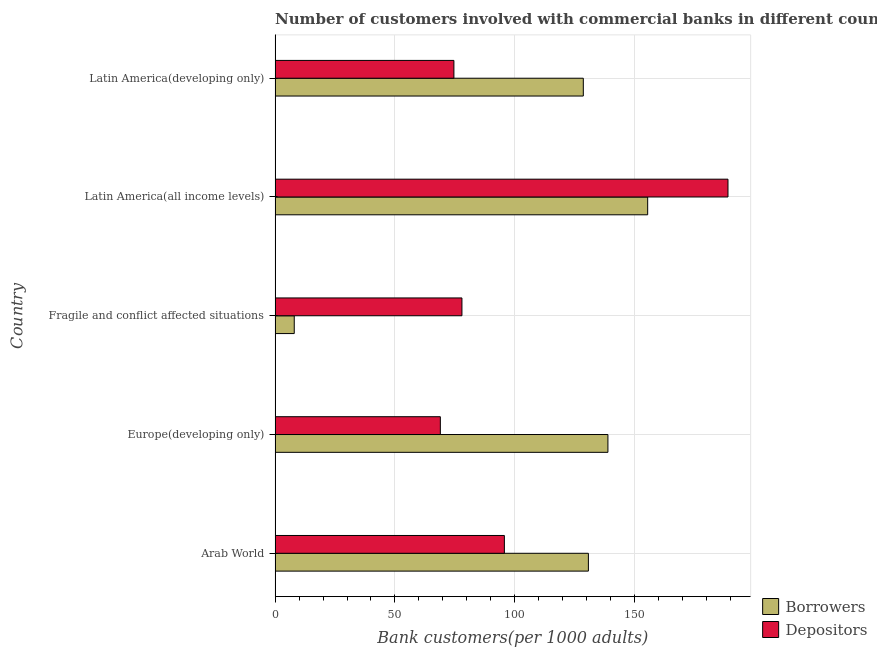How many bars are there on the 4th tick from the bottom?
Keep it short and to the point. 2. What is the label of the 1st group of bars from the top?
Provide a succinct answer. Latin America(developing only). What is the number of depositors in Latin America(developing only)?
Keep it short and to the point. 74.6. Across all countries, what is the maximum number of borrowers?
Your response must be concise. 155.43. Across all countries, what is the minimum number of borrowers?
Keep it short and to the point. 7.99. In which country was the number of depositors maximum?
Offer a very short reply. Latin America(all income levels). In which country was the number of borrowers minimum?
Your answer should be very brief. Fragile and conflict affected situations. What is the total number of borrowers in the graph?
Make the answer very short. 561.55. What is the difference between the number of depositors in Arab World and that in Europe(developing only)?
Offer a very short reply. 26.71. What is the difference between the number of depositors in Latin America(developing only) and the number of borrowers in Fragile and conflict affected situations?
Provide a short and direct response. 66.61. What is the average number of depositors per country?
Your answer should be very brief. 101.22. What is the difference between the number of depositors and number of borrowers in Arab World?
Keep it short and to the point. -35.05. In how many countries, is the number of borrowers greater than 30 ?
Make the answer very short. 4. What is the ratio of the number of borrowers in Europe(developing only) to that in Latin America(all income levels)?
Give a very brief answer. 0.89. Is the number of depositors in Europe(developing only) less than that in Fragile and conflict affected situations?
Your response must be concise. Yes. Is the difference between the number of depositors in Europe(developing only) and Fragile and conflict affected situations greater than the difference between the number of borrowers in Europe(developing only) and Fragile and conflict affected situations?
Your answer should be compact. No. What is the difference between the highest and the second highest number of borrowers?
Provide a short and direct response. 16.58. What is the difference between the highest and the lowest number of borrowers?
Ensure brevity in your answer.  147.44. In how many countries, is the number of depositors greater than the average number of depositors taken over all countries?
Give a very brief answer. 1. Is the sum of the number of borrowers in Arab World and Latin America(developing only) greater than the maximum number of depositors across all countries?
Keep it short and to the point. Yes. What does the 1st bar from the top in Latin America(developing only) represents?
Provide a succinct answer. Depositors. What does the 2nd bar from the bottom in Fragile and conflict affected situations represents?
Your response must be concise. Depositors. How many bars are there?
Make the answer very short. 10. Are all the bars in the graph horizontal?
Your answer should be compact. Yes. Does the graph contain any zero values?
Offer a very short reply. No. What is the title of the graph?
Provide a succinct answer. Number of customers involved with commercial banks in different countries. Does "Highest 10% of population" appear as one of the legend labels in the graph?
Give a very brief answer. No. What is the label or title of the X-axis?
Offer a very short reply. Bank customers(per 1000 adults). What is the Bank customers(per 1000 adults) in Borrowers in Arab World?
Provide a short and direct response. 130.7. What is the Bank customers(per 1000 adults) in Depositors in Arab World?
Ensure brevity in your answer.  95.65. What is the Bank customers(per 1000 adults) of Borrowers in Europe(developing only)?
Keep it short and to the point. 138.85. What is the Bank customers(per 1000 adults) in Depositors in Europe(developing only)?
Give a very brief answer. 68.94. What is the Bank customers(per 1000 adults) of Borrowers in Fragile and conflict affected situations?
Your response must be concise. 7.99. What is the Bank customers(per 1000 adults) of Depositors in Fragile and conflict affected situations?
Your answer should be compact. 77.95. What is the Bank customers(per 1000 adults) in Borrowers in Latin America(all income levels)?
Provide a succinct answer. 155.43. What is the Bank customers(per 1000 adults) of Depositors in Latin America(all income levels)?
Your answer should be compact. 188.93. What is the Bank customers(per 1000 adults) in Borrowers in Latin America(developing only)?
Your response must be concise. 128.58. What is the Bank customers(per 1000 adults) of Depositors in Latin America(developing only)?
Offer a terse response. 74.6. Across all countries, what is the maximum Bank customers(per 1000 adults) in Borrowers?
Your response must be concise. 155.43. Across all countries, what is the maximum Bank customers(per 1000 adults) of Depositors?
Provide a succinct answer. 188.93. Across all countries, what is the minimum Bank customers(per 1000 adults) of Borrowers?
Offer a very short reply. 7.99. Across all countries, what is the minimum Bank customers(per 1000 adults) of Depositors?
Offer a terse response. 68.94. What is the total Bank customers(per 1000 adults) in Borrowers in the graph?
Your answer should be very brief. 561.55. What is the total Bank customers(per 1000 adults) in Depositors in the graph?
Make the answer very short. 506.08. What is the difference between the Bank customers(per 1000 adults) in Borrowers in Arab World and that in Europe(developing only)?
Keep it short and to the point. -8.15. What is the difference between the Bank customers(per 1000 adults) of Depositors in Arab World and that in Europe(developing only)?
Ensure brevity in your answer.  26.71. What is the difference between the Bank customers(per 1000 adults) of Borrowers in Arab World and that in Fragile and conflict affected situations?
Give a very brief answer. 122.7. What is the difference between the Bank customers(per 1000 adults) of Depositors in Arab World and that in Fragile and conflict affected situations?
Your answer should be compact. 17.7. What is the difference between the Bank customers(per 1000 adults) in Borrowers in Arab World and that in Latin America(all income levels)?
Provide a succinct answer. -24.74. What is the difference between the Bank customers(per 1000 adults) of Depositors in Arab World and that in Latin America(all income levels)?
Your response must be concise. -93.28. What is the difference between the Bank customers(per 1000 adults) of Borrowers in Arab World and that in Latin America(developing only)?
Your response must be concise. 2.12. What is the difference between the Bank customers(per 1000 adults) of Depositors in Arab World and that in Latin America(developing only)?
Ensure brevity in your answer.  21.05. What is the difference between the Bank customers(per 1000 adults) in Borrowers in Europe(developing only) and that in Fragile and conflict affected situations?
Keep it short and to the point. 130.86. What is the difference between the Bank customers(per 1000 adults) of Depositors in Europe(developing only) and that in Fragile and conflict affected situations?
Make the answer very short. -9.01. What is the difference between the Bank customers(per 1000 adults) in Borrowers in Europe(developing only) and that in Latin America(all income levels)?
Offer a very short reply. -16.58. What is the difference between the Bank customers(per 1000 adults) of Depositors in Europe(developing only) and that in Latin America(all income levels)?
Offer a terse response. -119.99. What is the difference between the Bank customers(per 1000 adults) of Borrowers in Europe(developing only) and that in Latin America(developing only)?
Your answer should be compact. 10.27. What is the difference between the Bank customers(per 1000 adults) of Depositors in Europe(developing only) and that in Latin America(developing only)?
Provide a short and direct response. -5.66. What is the difference between the Bank customers(per 1000 adults) of Borrowers in Fragile and conflict affected situations and that in Latin America(all income levels)?
Give a very brief answer. -147.44. What is the difference between the Bank customers(per 1000 adults) of Depositors in Fragile and conflict affected situations and that in Latin America(all income levels)?
Your response must be concise. -110.98. What is the difference between the Bank customers(per 1000 adults) in Borrowers in Fragile and conflict affected situations and that in Latin America(developing only)?
Provide a succinct answer. -120.59. What is the difference between the Bank customers(per 1000 adults) of Depositors in Fragile and conflict affected situations and that in Latin America(developing only)?
Ensure brevity in your answer.  3.35. What is the difference between the Bank customers(per 1000 adults) of Borrowers in Latin America(all income levels) and that in Latin America(developing only)?
Offer a very short reply. 26.85. What is the difference between the Bank customers(per 1000 adults) of Depositors in Latin America(all income levels) and that in Latin America(developing only)?
Provide a short and direct response. 114.33. What is the difference between the Bank customers(per 1000 adults) of Borrowers in Arab World and the Bank customers(per 1000 adults) of Depositors in Europe(developing only)?
Make the answer very short. 61.76. What is the difference between the Bank customers(per 1000 adults) of Borrowers in Arab World and the Bank customers(per 1000 adults) of Depositors in Fragile and conflict affected situations?
Give a very brief answer. 52.75. What is the difference between the Bank customers(per 1000 adults) of Borrowers in Arab World and the Bank customers(per 1000 adults) of Depositors in Latin America(all income levels)?
Make the answer very short. -58.24. What is the difference between the Bank customers(per 1000 adults) in Borrowers in Arab World and the Bank customers(per 1000 adults) in Depositors in Latin America(developing only)?
Your response must be concise. 56.1. What is the difference between the Bank customers(per 1000 adults) in Borrowers in Europe(developing only) and the Bank customers(per 1000 adults) in Depositors in Fragile and conflict affected situations?
Provide a short and direct response. 60.9. What is the difference between the Bank customers(per 1000 adults) in Borrowers in Europe(developing only) and the Bank customers(per 1000 adults) in Depositors in Latin America(all income levels)?
Your response must be concise. -50.09. What is the difference between the Bank customers(per 1000 adults) in Borrowers in Europe(developing only) and the Bank customers(per 1000 adults) in Depositors in Latin America(developing only)?
Your answer should be very brief. 64.25. What is the difference between the Bank customers(per 1000 adults) of Borrowers in Fragile and conflict affected situations and the Bank customers(per 1000 adults) of Depositors in Latin America(all income levels)?
Your answer should be very brief. -180.94. What is the difference between the Bank customers(per 1000 adults) in Borrowers in Fragile and conflict affected situations and the Bank customers(per 1000 adults) in Depositors in Latin America(developing only)?
Offer a terse response. -66.61. What is the difference between the Bank customers(per 1000 adults) in Borrowers in Latin America(all income levels) and the Bank customers(per 1000 adults) in Depositors in Latin America(developing only)?
Provide a short and direct response. 80.83. What is the average Bank customers(per 1000 adults) in Borrowers per country?
Offer a terse response. 112.31. What is the average Bank customers(per 1000 adults) of Depositors per country?
Provide a succinct answer. 101.22. What is the difference between the Bank customers(per 1000 adults) in Borrowers and Bank customers(per 1000 adults) in Depositors in Arab World?
Give a very brief answer. 35.05. What is the difference between the Bank customers(per 1000 adults) of Borrowers and Bank customers(per 1000 adults) of Depositors in Europe(developing only)?
Offer a terse response. 69.91. What is the difference between the Bank customers(per 1000 adults) in Borrowers and Bank customers(per 1000 adults) in Depositors in Fragile and conflict affected situations?
Give a very brief answer. -69.96. What is the difference between the Bank customers(per 1000 adults) of Borrowers and Bank customers(per 1000 adults) of Depositors in Latin America(all income levels)?
Provide a short and direct response. -33.5. What is the difference between the Bank customers(per 1000 adults) of Borrowers and Bank customers(per 1000 adults) of Depositors in Latin America(developing only)?
Offer a very short reply. 53.98. What is the ratio of the Bank customers(per 1000 adults) of Borrowers in Arab World to that in Europe(developing only)?
Offer a terse response. 0.94. What is the ratio of the Bank customers(per 1000 adults) of Depositors in Arab World to that in Europe(developing only)?
Give a very brief answer. 1.39. What is the ratio of the Bank customers(per 1000 adults) in Borrowers in Arab World to that in Fragile and conflict affected situations?
Ensure brevity in your answer.  16.35. What is the ratio of the Bank customers(per 1000 adults) of Depositors in Arab World to that in Fragile and conflict affected situations?
Offer a very short reply. 1.23. What is the ratio of the Bank customers(per 1000 adults) of Borrowers in Arab World to that in Latin America(all income levels)?
Keep it short and to the point. 0.84. What is the ratio of the Bank customers(per 1000 adults) of Depositors in Arab World to that in Latin America(all income levels)?
Your answer should be compact. 0.51. What is the ratio of the Bank customers(per 1000 adults) in Borrowers in Arab World to that in Latin America(developing only)?
Offer a terse response. 1.02. What is the ratio of the Bank customers(per 1000 adults) of Depositors in Arab World to that in Latin America(developing only)?
Keep it short and to the point. 1.28. What is the ratio of the Bank customers(per 1000 adults) in Borrowers in Europe(developing only) to that in Fragile and conflict affected situations?
Your answer should be compact. 17.37. What is the ratio of the Bank customers(per 1000 adults) of Depositors in Europe(developing only) to that in Fragile and conflict affected situations?
Provide a short and direct response. 0.88. What is the ratio of the Bank customers(per 1000 adults) in Borrowers in Europe(developing only) to that in Latin America(all income levels)?
Keep it short and to the point. 0.89. What is the ratio of the Bank customers(per 1000 adults) in Depositors in Europe(developing only) to that in Latin America(all income levels)?
Make the answer very short. 0.36. What is the ratio of the Bank customers(per 1000 adults) of Borrowers in Europe(developing only) to that in Latin America(developing only)?
Your answer should be very brief. 1.08. What is the ratio of the Bank customers(per 1000 adults) in Depositors in Europe(developing only) to that in Latin America(developing only)?
Give a very brief answer. 0.92. What is the ratio of the Bank customers(per 1000 adults) of Borrowers in Fragile and conflict affected situations to that in Latin America(all income levels)?
Offer a terse response. 0.05. What is the ratio of the Bank customers(per 1000 adults) of Depositors in Fragile and conflict affected situations to that in Latin America(all income levels)?
Your response must be concise. 0.41. What is the ratio of the Bank customers(per 1000 adults) in Borrowers in Fragile and conflict affected situations to that in Latin America(developing only)?
Offer a very short reply. 0.06. What is the ratio of the Bank customers(per 1000 adults) of Depositors in Fragile and conflict affected situations to that in Latin America(developing only)?
Keep it short and to the point. 1.04. What is the ratio of the Bank customers(per 1000 adults) in Borrowers in Latin America(all income levels) to that in Latin America(developing only)?
Keep it short and to the point. 1.21. What is the ratio of the Bank customers(per 1000 adults) in Depositors in Latin America(all income levels) to that in Latin America(developing only)?
Your answer should be very brief. 2.53. What is the difference between the highest and the second highest Bank customers(per 1000 adults) in Borrowers?
Offer a terse response. 16.58. What is the difference between the highest and the second highest Bank customers(per 1000 adults) in Depositors?
Provide a succinct answer. 93.28. What is the difference between the highest and the lowest Bank customers(per 1000 adults) of Borrowers?
Your response must be concise. 147.44. What is the difference between the highest and the lowest Bank customers(per 1000 adults) of Depositors?
Keep it short and to the point. 119.99. 